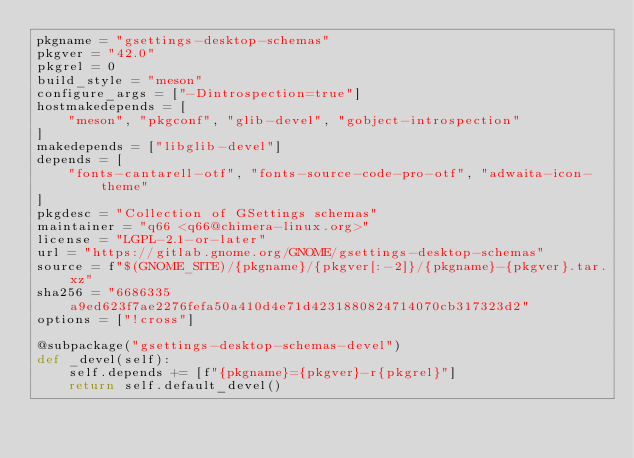<code> <loc_0><loc_0><loc_500><loc_500><_Python_>pkgname = "gsettings-desktop-schemas"
pkgver = "42.0"
pkgrel = 0
build_style = "meson"
configure_args = ["-Dintrospection=true"]
hostmakedepends = [
    "meson", "pkgconf", "glib-devel", "gobject-introspection"
]
makedepends = ["libglib-devel"]
depends = [
    "fonts-cantarell-otf", "fonts-source-code-pro-otf", "adwaita-icon-theme"
]
pkgdesc = "Collection of GSettings schemas"
maintainer = "q66 <q66@chimera-linux.org>"
license = "LGPL-2.1-or-later"
url = "https://gitlab.gnome.org/GNOME/gsettings-desktop-schemas"
source = f"$(GNOME_SITE)/{pkgname}/{pkgver[:-2]}/{pkgname}-{pkgver}.tar.xz"
sha256 = "6686335a9ed623f7ae2276fefa50a410d4e71d4231880824714070cb317323d2"
options = ["!cross"]

@subpackage("gsettings-desktop-schemas-devel")
def _devel(self):
    self.depends += [f"{pkgname}={pkgver}-r{pkgrel}"]
    return self.default_devel()
</code> 